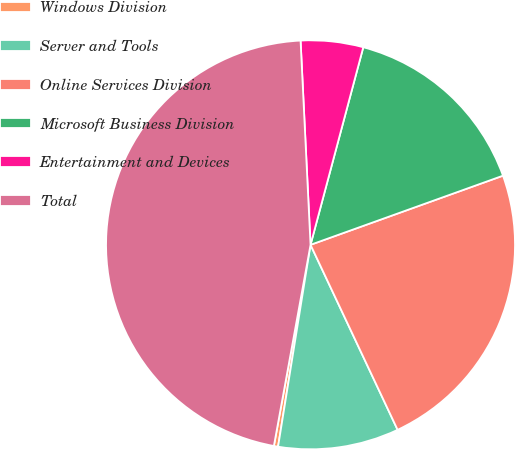<chart> <loc_0><loc_0><loc_500><loc_500><pie_chart><fcel>Windows Division<fcel>Server and Tools<fcel>Online Services Division<fcel>Microsoft Business Division<fcel>Entertainment and Devices<fcel>Total<nl><fcel>0.33%<fcel>9.54%<fcel>23.49%<fcel>15.36%<fcel>4.93%<fcel>46.36%<nl></chart> 